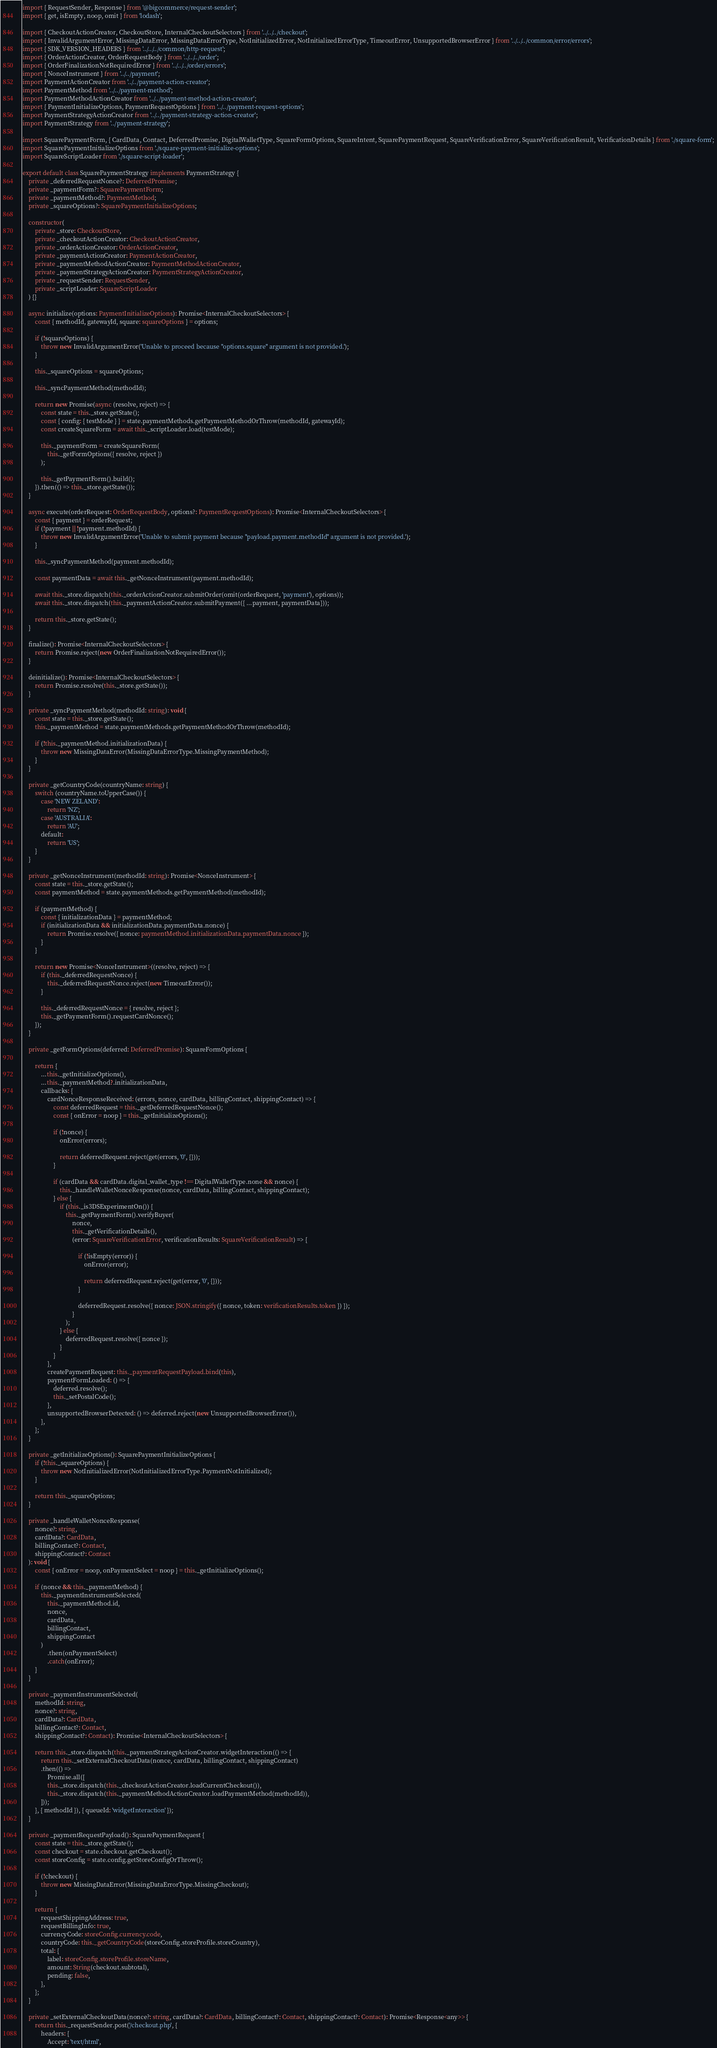Convert code to text. <code><loc_0><loc_0><loc_500><loc_500><_TypeScript_>import { RequestSender, Response } from '@bigcommerce/request-sender';
import { get, isEmpty, noop, omit } from 'lodash';

import { CheckoutActionCreator, CheckoutStore, InternalCheckoutSelectors } from '../../../checkout';
import { InvalidArgumentError, MissingDataError, MissingDataErrorType, NotInitializedError, NotInitializedErrorType, TimeoutError, UnsupportedBrowserError } from '../../../common/error/errors';
import { SDK_VERSION_HEADERS } from '../../../common/http-request';
import { OrderActionCreator, OrderRequestBody } from '../../../order';
import { OrderFinalizationNotRequiredError } from '../../../order/errors';
import { NonceInstrument } from '../../payment';
import PaymentActionCreator from '../../payment-action-creator';
import PaymentMethod from '../../payment-method';
import PaymentMethodActionCreator from '../../payment-method-action-creator';
import { PaymentInitializeOptions, PaymentRequestOptions } from '../../payment-request-options';
import PaymentStrategyActionCreator from '../../payment-strategy-action-creator';
import PaymentStrategy from '../payment-strategy';

import SquarePaymentForm, { CardData, Contact, DeferredPromise, DigitalWalletType, SquareFormOptions, SquareIntent, SquarePaymentRequest, SquareVerificationError, SquareVerificationResult, VerificationDetails } from './square-form';
import SquarePaymentInitializeOptions from './square-payment-initialize-options';
import SquareScriptLoader from './square-script-loader';

export default class SquarePaymentStrategy implements PaymentStrategy {
    private _deferredRequestNonce?: DeferredPromise;
    private _paymentForm?: SquarePaymentForm;
    private _paymentMethod?: PaymentMethod;
    private _squareOptions?: SquarePaymentInitializeOptions;

    constructor(
        private _store: CheckoutStore,
        private _checkoutActionCreator: CheckoutActionCreator,
        private _orderActionCreator: OrderActionCreator,
        private _paymentActionCreator: PaymentActionCreator,
        private _paymentMethodActionCreator: PaymentMethodActionCreator,
        private _paymentStrategyActionCreator: PaymentStrategyActionCreator,
        private _requestSender: RequestSender,
        private _scriptLoader: SquareScriptLoader
    ) {}

    async initialize(options: PaymentInitializeOptions): Promise<InternalCheckoutSelectors> {
        const { methodId, gatewayId, square: squareOptions } = options;

        if (!squareOptions) {
            throw new InvalidArgumentError('Unable to proceed because "options.square" argument is not provided.');
        }

        this._squareOptions = squareOptions;

        this._syncPaymentMethod(methodId);

        return new Promise(async (resolve, reject) => {
            const state = this._store.getState();
            const { config: { testMode } } = state.paymentMethods.getPaymentMethodOrThrow(methodId, gatewayId);
            const createSquareForm = await this._scriptLoader.load(testMode);

            this._paymentForm = createSquareForm(
                this._getFormOptions({ resolve, reject })
            );

            this._getPaymentForm().build();
        }).then(() => this._store.getState());
    }

    async execute(orderRequest: OrderRequestBody, options?: PaymentRequestOptions): Promise<InternalCheckoutSelectors> {
        const { payment } = orderRequest;
        if (!payment || !payment.methodId) {
            throw new InvalidArgumentError('Unable to submit payment because "payload.payment.methodId" argument is not provided.');
        }

        this._syncPaymentMethod(payment.methodId);

        const paymentData = await this._getNonceInstrument(payment.methodId);

        await this._store.dispatch(this._orderActionCreator.submitOrder(omit(orderRequest, 'payment'), options));
        await this._store.dispatch(this._paymentActionCreator.submitPayment({ ...payment, paymentData}));

        return this._store.getState();
    }

    finalize(): Promise<InternalCheckoutSelectors> {
        return Promise.reject(new OrderFinalizationNotRequiredError());
    }

    deinitialize(): Promise<InternalCheckoutSelectors> {
        return Promise.resolve(this._store.getState());
    }

    private _syncPaymentMethod(methodId: string): void {
        const state = this._store.getState();
        this._paymentMethod = state.paymentMethods.getPaymentMethodOrThrow(methodId);

        if (!this._paymentMethod.initializationData) {
            throw new MissingDataError(MissingDataErrorType.MissingPaymentMethod);
        }
    }

    private _getCountryCode(countryName: string) {
        switch (countryName.toUpperCase()) {
            case 'NEW ZELAND':
                return 'NZ';
            case 'AUSTRALIA':
                return 'AU';
            default:
                return 'US';
        }
    }

    private _getNonceInstrument(methodId: string): Promise<NonceInstrument> {
        const state = this._store.getState();
        const paymentMethod = state.paymentMethods.getPaymentMethod(methodId);

        if (paymentMethod) {
            const { initializationData } = paymentMethod;
            if (initializationData && initializationData.paymentData.nonce) {
                return Promise.resolve({ nonce: paymentMethod.initializationData.paymentData.nonce });
            }
        }

        return new Promise<NonceInstrument>((resolve, reject) => {
            if (this._deferredRequestNonce) {
                this._deferredRequestNonce.reject(new TimeoutError());
            }

            this._deferredRequestNonce = { resolve, reject };
            this._getPaymentForm().requestCardNonce();
        });
    }

    private _getFormOptions(deferred: DeferredPromise): SquareFormOptions {

        return {
            ...this._getInitializeOptions(),
            ...this._paymentMethod?.initializationData,
            callbacks: {
                cardNonceResponseReceived: (errors, nonce, cardData, billingContact, shippingContact) => {
                    const deferredRequest = this._getDeferredRequestNonce();
                    const { onError = noop } = this._getInitializeOptions();

                    if (!nonce) {
                        onError(errors);

                        return deferredRequest.reject(get(errors, '0', {}));
                    }

                    if (cardData && cardData.digital_wallet_type !== DigitalWalletType.none && nonce) {
                        this._handleWalletNonceResponse(nonce, cardData, billingContact, shippingContact);
                    } else {
                        if (this._is3DSExperimentOn()) {
                            this._getPaymentForm().verifyBuyer(
                                nonce,
                                this._getVerificationDetails(),
                                (error: SquareVerificationError, verificationResults: SquareVerificationResult) => {

                                    if (!isEmpty(error)) {
                                        onError(error);

                                        return deferredRequest.reject(get(error, '0', {}));
                                    }

                                    deferredRequest.resolve({ nonce: JSON.stringify({ nonce, token: verificationResults.token }) });
                                }
                            );
                        } else {
                            deferredRequest.resolve({ nonce });
                        }
                    }
                },
                createPaymentRequest: this._paymentRequestPayload.bind(this),
                paymentFormLoaded: () => {
                    deferred.resolve();
                    this._setPostalCode();
                },
                unsupportedBrowserDetected: () => deferred.reject(new UnsupportedBrowserError()),
            },
        };
    }

    private _getInitializeOptions(): SquarePaymentInitializeOptions {
        if (!this._squareOptions) {
            throw new NotInitializedError(NotInitializedErrorType.PaymentNotInitialized);
        }

        return this._squareOptions;
    }

    private _handleWalletNonceResponse(
        nonce?: string,
        cardData?: CardData,
        billingContact?: Contact,
        shippingContact?: Contact
    ): void {
        const { onError = noop, onPaymentSelect = noop } = this._getInitializeOptions();

        if (nonce && this._paymentMethod) {
            this._paymentInstrumentSelected(
                this._paymentMethod.id,
                nonce,
                cardData,
                billingContact,
                shippingContact
            )
                .then(onPaymentSelect)
                .catch(onError);
        }
    }

    private _paymentInstrumentSelected(
        methodId: string,
        nonce?: string,
        cardData?: CardData,
        billingContact?: Contact,
        shippingContact?: Contact): Promise<InternalCheckoutSelectors> {

        return this._store.dispatch(this._paymentStrategyActionCreator.widgetInteraction(() => {
            return this._setExternalCheckoutData(nonce, cardData, billingContact, shippingContact)
            .then(() =>
                Promise.all([
                this._store.dispatch(this._checkoutActionCreator.loadCurrentCheckout()),
                this._store.dispatch(this._paymentMethodActionCreator.loadPaymentMethod(methodId)),
            ]));
        }, { methodId }), { queueId: 'widgetInteraction' });
    }

    private _paymentRequestPayload(): SquarePaymentRequest {
        const state = this._store.getState();
        const checkout = state.checkout.getCheckout();
        const storeConfig = state.config.getStoreConfigOrThrow();

        if (!checkout) {
            throw new MissingDataError(MissingDataErrorType.MissingCheckout);
        }

        return {
            requestShippingAddress: true,
            requestBillingInfo: true,
            currencyCode: storeConfig.currency.code,
            countryCode: this._getCountryCode(storeConfig.storeProfile.storeCountry),
            total: {
                label: storeConfig.storeProfile.storeName,
                amount: String(checkout.subtotal),
                pending: false,
            },
        };
    }

    private _setExternalCheckoutData(nonce?: string, cardData?: CardData, billingContact?: Contact, shippingContact?: Contact): Promise<Response<any>> {
        return this._requestSender.post('/checkout.php', {
            headers: {
                Accept: 'text/html',</code> 